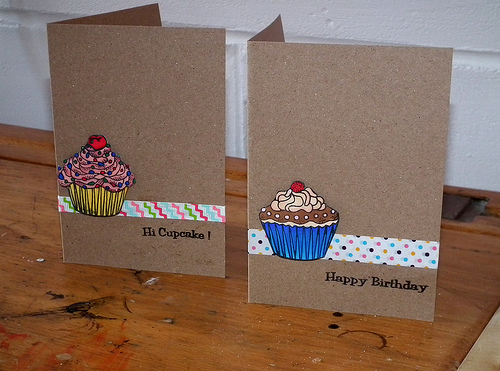<image>
Is there a cherry in front of the gumdrop? No. The cherry is not in front of the gumdrop. The spatial positioning shows a different relationship between these objects. Is there a card above the table? No. The card is not positioned above the table. The vertical arrangement shows a different relationship. 